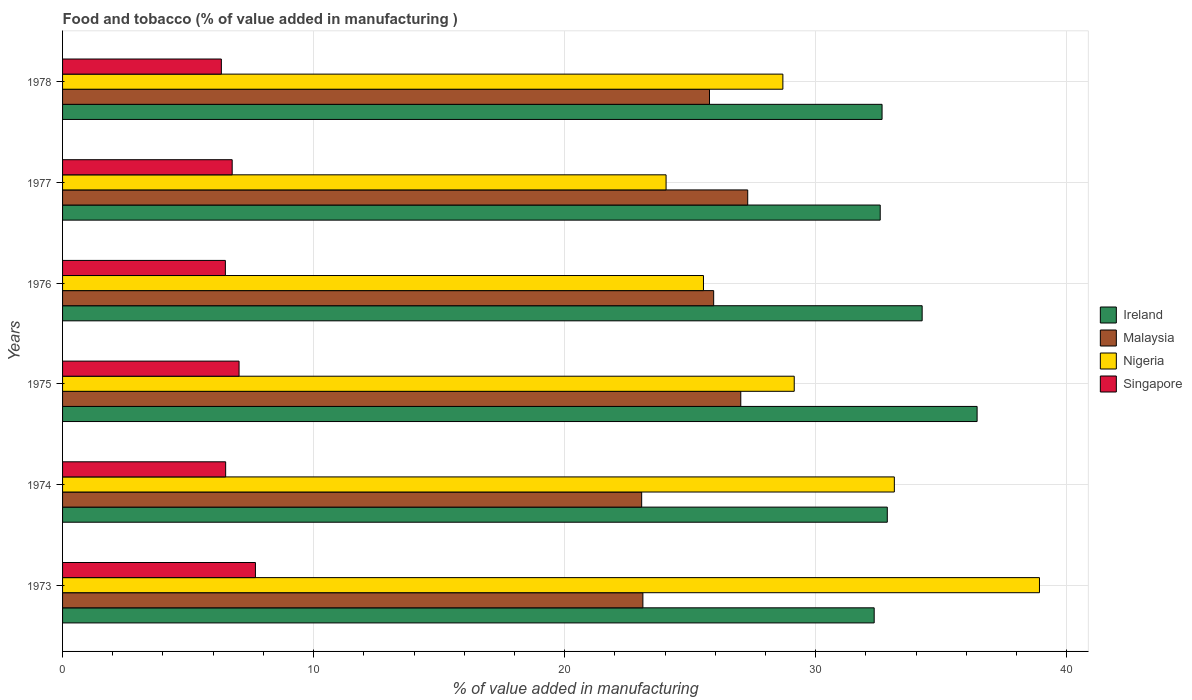Are the number of bars per tick equal to the number of legend labels?
Offer a very short reply. Yes. Are the number of bars on each tick of the Y-axis equal?
Keep it short and to the point. Yes. How many bars are there on the 1st tick from the top?
Provide a succinct answer. 4. What is the label of the 4th group of bars from the top?
Your answer should be compact. 1975. What is the value added in manufacturing food and tobacco in Malaysia in 1977?
Your response must be concise. 27.29. Across all years, what is the maximum value added in manufacturing food and tobacco in Nigeria?
Offer a terse response. 38.91. Across all years, what is the minimum value added in manufacturing food and tobacco in Malaysia?
Your answer should be compact. 23.07. In which year was the value added in manufacturing food and tobacco in Nigeria maximum?
Ensure brevity in your answer.  1973. In which year was the value added in manufacturing food and tobacco in Nigeria minimum?
Offer a very short reply. 1977. What is the total value added in manufacturing food and tobacco in Singapore in the graph?
Keep it short and to the point. 40.78. What is the difference between the value added in manufacturing food and tobacco in Nigeria in 1974 and that in 1975?
Provide a succinct answer. 3.99. What is the difference between the value added in manufacturing food and tobacco in Malaysia in 1978 and the value added in manufacturing food and tobacco in Ireland in 1974?
Offer a terse response. -7.08. What is the average value added in manufacturing food and tobacco in Singapore per year?
Your answer should be very brief. 6.8. In the year 1978, what is the difference between the value added in manufacturing food and tobacco in Ireland and value added in manufacturing food and tobacco in Singapore?
Make the answer very short. 26.32. What is the ratio of the value added in manufacturing food and tobacco in Ireland in 1974 to that in 1978?
Keep it short and to the point. 1.01. What is the difference between the highest and the second highest value added in manufacturing food and tobacco in Malaysia?
Make the answer very short. 0.28. What is the difference between the highest and the lowest value added in manufacturing food and tobacco in Malaysia?
Provide a succinct answer. 4.22. Is the sum of the value added in manufacturing food and tobacco in Malaysia in 1975 and 1978 greater than the maximum value added in manufacturing food and tobacco in Nigeria across all years?
Offer a terse response. Yes. Is it the case that in every year, the sum of the value added in manufacturing food and tobacco in Malaysia and value added in manufacturing food and tobacco in Nigeria is greater than the sum of value added in manufacturing food and tobacco in Ireland and value added in manufacturing food and tobacco in Singapore?
Make the answer very short. Yes. What does the 4th bar from the top in 1978 represents?
Ensure brevity in your answer.  Ireland. What does the 1st bar from the bottom in 1975 represents?
Your answer should be compact. Ireland. Are all the bars in the graph horizontal?
Your answer should be very brief. Yes. Are the values on the major ticks of X-axis written in scientific E-notation?
Offer a terse response. No. Does the graph contain any zero values?
Ensure brevity in your answer.  No. Where does the legend appear in the graph?
Your answer should be very brief. Center right. How are the legend labels stacked?
Provide a short and direct response. Vertical. What is the title of the graph?
Offer a very short reply. Food and tobacco (% of value added in manufacturing ). What is the label or title of the X-axis?
Provide a succinct answer. % of value added in manufacturing. What is the label or title of the Y-axis?
Ensure brevity in your answer.  Years. What is the % of value added in manufacturing in Ireland in 1973?
Your response must be concise. 32.33. What is the % of value added in manufacturing of Malaysia in 1973?
Provide a short and direct response. 23.12. What is the % of value added in manufacturing of Nigeria in 1973?
Your response must be concise. 38.91. What is the % of value added in manufacturing in Singapore in 1973?
Keep it short and to the point. 7.68. What is the % of value added in manufacturing of Ireland in 1974?
Provide a succinct answer. 32.85. What is the % of value added in manufacturing of Malaysia in 1974?
Offer a terse response. 23.07. What is the % of value added in manufacturing of Nigeria in 1974?
Keep it short and to the point. 33.13. What is the % of value added in manufacturing in Singapore in 1974?
Provide a short and direct response. 6.5. What is the % of value added in manufacturing in Ireland in 1975?
Provide a succinct answer. 36.43. What is the % of value added in manufacturing of Malaysia in 1975?
Your answer should be very brief. 27.02. What is the % of value added in manufacturing of Nigeria in 1975?
Provide a succinct answer. 29.15. What is the % of value added in manufacturing of Singapore in 1975?
Provide a short and direct response. 7.03. What is the % of value added in manufacturing in Ireland in 1976?
Ensure brevity in your answer.  34.24. What is the % of value added in manufacturing of Malaysia in 1976?
Give a very brief answer. 25.94. What is the % of value added in manufacturing of Nigeria in 1976?
Make the answer very short. 25.53. What is the % of value added in manufacturing of Singapore in 1976?
Offer a terse response. 6.49. What is the % of value added in manufacturing of Ireland in 1977?
Give a very brief answer. 32.57. What is the % of value added in manufacturing of Malaysia in 1977?
Keep it short and to the point. 27.29. What is the % of value added in manufacturing in Nigeria in 1977?
Provide a succinct answer. 24.04. What is the % of value added in manufacturing in Singapore in 1977?
Ensure brevity in your answer.  6.76. What is the % of value added in manufacturing in Ireland in 1978?
Ensure brevity in your answer.  32.64. What is the % of value added in manufacturing in Malaysia in 1978?
Provide a short and direct response. 25.77. What is the % of value added in manufacturing of Nigeria in 1978?
Keep it short and to the point. 28.69. What is the % of value added in manufacturing of Singapore in 1978?
Ensure brevity in your answer.  6.33. Across all years, what is the maximum % of value added in manufacturing in Ireland?
Offer a very short reply. 36.43. Across all years, what is the maximum % of value added in manufacturing of Malaysia?
Your response must be concise. 27.29. Across all years, what is the maximum % of value added in manufacturing of Nigeria?
Keep it short and to the point. 38.91. Across all years, what is the maximum % of value added in manufacturing of Singapore?
Make the answer very short. 7.68. Across all years, what is the minimum % of value added in manufacturing in Ireland?
Ensure brevity in your answer.  32.33. Across all years, what is the minimum % of value added in manufacturing in Malaysia?
Offer a very short reply. 23.07. Across all years, what is the minimum % of value added in manufacturing of Nigeria?
Provide a short and direct response. 24.04. Across all years, what is the minimum % of value added in manufacturing in Singapore?
Make the answer very short. 6.33. What is the total % of value added in manufacturing in Ireland in the graph?
Your response must be concise. 201.07. What is the total % of value added in manufacturing of Malaysia in the graph?
Your answer should be very brief. 152.2. What is the total % of value added in manufacturing of Nigeria in the graph?
Offer a terse response. 179.46. What is the total % of value added in manufacturing of Singapore in the graph?
Offer a very short reply. 40.78. What is the difference between the % of value added in manufacturing of Ireland in 1973 and that in 1974?
Make the answer very short. -0.52. What is the difference between the % of value added in manufacturing of Malaysia in 1973 and that in 1974?
Ensure brevity in your answer.  0.05. What is the difference between the % of value added in manufacturing of Nigeria in 1973 and that in 1974?
Make the answer very short. 5.78. What is the difference between the % of value added in manufacturing in Singapore in 1973 and that in 1974?
Offer a terse response. 1.19. What is the difference between the % of value added in manufacturing in Malaysia in 1973 and that in 1975?
Keep it short and to the point. -3.9. What is the difference between the % of value added in manufacturing in Nigeria in 1973 and that in 1975?
Provide a short and direct response. 9.77. What is the difference between the % of value added in manufacturing in Singapore in 1973 and that in 1975?
Offer a very short reply. 0.65. What is the difference between the % of value added in manufacturing in Ireland in 1973 and that in 1976?
Offer a very short reply. -1.91. What is the difference between the % of value added in manufacturing of Malaysia in 1973 and that in 1976?
Make the answer very short. -2.82. What is the difference between the % of value added in manufacturing in Nigeria in 1973 and that in 1976?
Your response must be concise. 13.38. What is the difference between the % of value added in manufacturing in Singapore in 1973 and that in 1976?
Give a very brief answer. 1.2. What is the difference between the % of value added in manufacturing in Ireland in 1973 and that in 1977?
Keep it short and to the point. -0.24. What is the difference between the % of value added in manufacturing in Malaysia in 1973 and that in 1977?
Ensure brevity in your answer.  -4.18. What is the difference between the % of value added in manufacturing in Nigeria in 1973 and that in 1977?
Your response must be concise. 14.87. What is the difference between the % of value added in manufacturing in Singapore in 1973 and that in 1977?
Offer a very short reply. 0.93. What is the difference between the % of value added in manufacturing in Ireland in 1973 and that in 1978?
Provide a short and direct response. -0.31. What is the difference between the % of value added in manufacturing of Malaysia in 1973 and that in 1978?
Keep it short and to the point. -2.65. What is the difference between the % of value added in manufacturing of Nigeria in 1973 and that in 1978?
Ensure brevity in your answer.  10.22. What is the difference between the % of value added in manufacturing of Singapore in 1973 and that in 1978?
Your answer should be very brief. 1.36. What is the difference between the % of value added in manufacturing in Ireland in 1974 and that in 1975?
Offer a terse response. -3.58. What is the difference between the % of value added in manufacturing of Malaysia in 1974 and that in 1975?
Ensure brevity in your answer.  -3.95. What is the difference between the % of value added in manufacturing of Nigeria in 1974 and that in 1975?
Provide a succinct answer. 3.99. What is the difference between the % of value added in manufacturing in Singapore in 1974 and that in 1975?
Provide a short and direct response. -0.53. What is the difference between the % of value added in manufacturing of Ireland in 1974 and that in 1976?
Your response must be concise. -1.39. What is the difference between the % of value added in manufacturing in Malaysia in 1974 and that in 1976?
Your answer should be very brief. -2.87. What is the difference between the % of value added in manufacturing of Nigeria in 1974 and that in 1976?
Give a very brief answer. 7.6. What is the difference between the % of value added in manufacturing of Singapore in 1974 and that in 1976?
Offer a terse response. 0.01. What is the difference between the % of value added in manufacturing of Ireland in 1974 and that in 1977?
Give a very brief answer. 0.28. What is the difference between the % of value added in manufacturing of Malaysia in 1974 and that in 1977?
Offer a terse response. -4.22. What is the difference between the % of value added in manufacturing in Nigeria in 1974 and that in 1977?
Keep it short and to the point. 9.09. What is the difference between the % of value added in manufacturing of Singapore in 1974 and that in 1977?
Your response must be concise. -0.26. What is the difference between the % of value added in manufacturing in Ireland in 1974 and that in 1978?
Your answer should be very brief. 0.21. What is the difference between the % of value added in manufacturing of Malaysia in 1974 and that in 1978?
Keep it short and to the point. -2.7. What is the difference between the % of value added in manufacturing in Nigeria in 1974 and that in 1978?
Provide a succinct answer. 4.44. What is the difference between the % of value added in manufacturing of Singapore in 1974 and that in 1978?
Provide a short and direct response. 0.17. What is the difference between the % of value added in manufacturing of Ireland in 1975 and that in 1976?
Offer a terse response. 2.19. What is the difference between the % of value added in manufacturing in Malaysia in 1975 and that in 1976?
Keep it short and to the point. 1.08. What is the difference between the % of value added in manufacturing in Nigeria in 1975 and that in 1976?
Give a very brief answer. 3.62. What is the difference between the % of value added in manufacturing in Singapore in 1975 and that in 1976?
Offer a terse response. 0.55. What is the difference between the % of value added in manufacturing in Ireland in 1975 and that in 1977?
Ensure brevity in your answer.  3.86. What is the difference between the % of value added in manufacturing in Malaysia in 1975 and that in 1977?
Your response must be concise. -0.28. What is the difference between the % of value added in manufacturing of Nigeria in 1975 and that in 1977?
Provide a succinct answer. 5.11. What is the difference between the % of value added in manufacturing in Singapore in 1975 and that in 1977?
Your response must be concise. 0.27. What is the difference between the % of value added in manufacturing in Ireland in 1975 and that in 1978?
Ensure brevity in your answer.  3.79. What is the difference between the % of value added in manufacturing of Malaysia in 1975 and that in 1978?
Offer a terse response. 1.25. What is the difference between the % of value added in manufacturing of Nigeria in 1975 and that in 1978?
Your answer should be very brief. 0.45. What is the difference between the % of value added in manufacturing of Singapore in 1975 and that in 1978?
Ensure brevity in your answer.  0.71. What is the difference between the % of value added in manufacturing of Ireland in 1976 and that in 1977?
Make the answer very short. 1.67. What is the difference between the % of value added in manufacturing of Malaysia in 1976 and that in 1977?
Keep it short and to the point. -1.36. What is the difference between the % of value added in manufacturing of Nigeria in 1976 and that in 1977?
Ensure brevity in your answer.  1.49. What is the difference between the % of value added in manufacturing of Singapore in 1976 and that in 1977?
Your response must be concise. -0.27. What is the difference between the % of value added in manufacturing of Ireland in 1976 and that in 1978?
Offer a very short reply. 1.6. What is the difference between the % of value added in manufacturing of Malaysia in 1976 and that in 1978?
Offer a terse response. 0.17. What is the difference between the % of value added in manufacturing of Nigeria in 1976 and that in 1978?
Keep it short and to the point. -3.16. What is the difference between the % of value added in manufacturing in Singapore in 1976 and that in 1978?
Ensure brevity in your answer.  0.16. What is the difference between the % of value added in manufacturing in Ireland in 1977 and that in 1978?
Keep it short and to the point. -0.07. What is the difference between the % of value added in manufacturing in Malaysia in 1977 and that in 1978?
Make the answer very short. 1.52. What is the difference between the % of value added in manufacturing in Nigeria in 1977 and that in 1978?
Offer a very short reply. -4.65. What is the difference between the % of value added in manufacturing in Singapore in 1977 and that in 1978?
Your answer should be very brief. 0.43. What is the difference between the % of value added in manufacturing in Ireland in 1973 and the % of value added in manufacturing in Malaysia in 1974?
Ensure brevity in your answer.  9.26. What is the difference between the % of value added in manufacturing in Ireland in 1973 and the % of value added in manufacturing in Nigeria in 1974?
Ensure brevity in your answer.  -0.8. What is the difference between the % of value added in manufacturing of Ireland in 1973 and the % of value added in manufacturing of Singapore in 1974?
Your answer should be compact. 25.83. What is the difference between the % of value added in manufacturing of Malaysia in 1973 and the % of value added in manufacturing of Nigeria in 1974?
Provide a short and direct response. -10.02. What is the difference between the % of value added in manufacturing of Malaysia in 1973 and the % of value added in manufacturing of Singapore in 1974?
Your answer should be compact. 16.62. What is the difference between the % of value added in manufacturing in Nigeria in 1973 and the % of value added in manufacturing in Singapore in 1974?
Offer a very short reply. 32.42. What is the difference between the % of value added in manufacturing in Ireland in 1973 and the % of value added in manufacturing in Malaysia in 1975?
Make the answer very short. 5.31. What is the difference between the % of value added in manufacturing of Ireland in 1973 and the % of value added in manufacturing of Nigeria in 1975?
Make the answer very short. 3.18. What is the difference between the % of value added in manufacturing of Ireland in 1973 and the % of value added in manufacturing of Singapore in 1975?
Your answer should be very brief. 25.3. What is the difference between the % of value added in manufacturing of Malaysia in 1973 and the % of value added in manufacturing of Nigeria in 1975?
Give a very brief answer. -6.03. What is the difference between the % of value added in manufacturing in Malaysia in 1973 and the % of value added in manufacturing in Singapore in 1975?
Offer a terse response. 16.09. What is the difference between the % of value added in manufacturing of Nigeria in 1973 and the % of value added in manufacturing of Singapore in 1975?
Your answer should be compact. 31.88. What is the difference between the % of value added in manufacturing of Ireland in 1973 and the % of value added in manufacturing of Malaysia in 1976?
Keep it short and to the point. 6.39. What is the difference between the % of value added in manufacturing in Ireland in 1973 and the % of value added in manufacturing in Nigeria in 1976?
Your answer should be very brief. 6.8. What is the difference between the % of value added in manufacturing of Ireland in 1973 and the % of value added in manufacturing of Singapore in 1976?
Ensure brevity in your answer.  25.84. What is the difference between the % of value added in manufacturing in Malaysia in 1973 and the % of value added in manufacturing in Nigeria in 1976?
Provide a short and direct response. -2.41. What is the difference between the % of value added in manufacturing in Malaysia in 1973 and the % of value added in manufacturing in Singapore in 1976?
Your response must be concise. 16.63. What is the difference between the % of value added in manufacturing of Nigeria in 1973 and the % of value added in manufacturing of Singapore in 1976?
Offer a terse response. 32.43. What is the difference between the % of value added in manufacturing in Ireland in 1973 and the % of value added in manufacturing in Malaysia in 1977?
Provide a short and direct response. 5.04. What is the difference between the % of value added in manufacturing of Ireland in 1973 and the % of value added in manufacturing of Nigeria in 1977?
Ensure brevity in your answer.  8.29. What is the difference between the % of value added in manufacturing of Ireland in 1973 and the % of value added in manufacturing of Singapore in 1977?
Provide a succinct answer. 25.57. What is the difference between the % of value added in manufacturing of Malaysia in 1973 and the % of value added in manufacturing of Nigeria in 1977?
Provide a short and direct response. -0.92. What is the difference between the % of value added in manufacturing of Malaysia in 1973 and the % of value added in manufacturing of Singapore in 1977?
Your answer should be compact. 16.36. What is the difference between the % of value added in manufacturing in Nigeria in 1973 and the % of value added in manufacturing in Singapore in 1977?
Your answer should be very brief. 32.16. What is the difference between the % of value added in manufacturing in Ireland in 1973 and the % of value added in manufacturing in Malaysia in 1978?
Provide a short and direct response. 6.56. What is the difference between the % of value added in manufacturing of Ireland in 1973 and the % of value added in manufacturing of Nigeria in 1978?
Your answer should be very brief. 3.64. What is the difference between the % of value added in manufacturing of Ireland in 1973 and the % of value added in manufacturing of Singapore in 1978?
Provide a succinct answer. 26. What is the difference between the % of value added in manufacturing of Malaysia in 1973 and the % of value added in manufacturing of Nigeria in 1978?
Offer a terse response. -5.58. What is the difference between the % of value added in manufacturing of Malaysia in 1973 and the % of value added in manufacturing of Singapore in 1978?
Give a very brief answer. 16.79. What is the difference between the % of value added in manufacturing of Nigeria in 1973 and the % of value added in manufacturing of Singapore in 1978?
Make the answer very short. 32.59. What is the difference between the % of value added in manufacturing in Ireland in 1974 and the % of value added in manufacturing in Malaysia in 1975?
Ensure brevity in your answer.  5.84. What is the difference between the % of value added in manufacturing of Ireland in 1974 and the % of value added in manufacturing of Nigeria in 1975?
Your response must be concise. 3.71. What is the difference between the % of value added in manufacturing of Ireland in 1974 and the % of value added in manufacturing of Singapore in 1975?
Provide a succinct answer. 25.82. What is the difference between the % of value added in manufacturing in Malaysia in 1974 and the % of value added in manufacturing in Nigeria in 1975?
Provide a short and direct response. -6.08. What is the difference between the % of value added in manufacturing in Malaysia in 1974 and the % of value added in manufacturing in Singapore in 1975?
Keep it short and to the point. 16.04. What is the difference between the % of value added in manufacturing in Nigeria in 1974 and the % of value added in manufacturing in Singapore in 1975?
Provide a succinct answer. 26.1. What is the difference between the % of value added in manufacturing of Ireland in 1974 and the % of value added in manufacturing of Malaysia in 1976?
Your answer should be very brief. 6.92. What is the difference between the % of value added in manufacturing of Ireland in 1974 and the % of value added in manufacturing of Nigeria in 1976?
Make the answer very short. 7.32. What is the difference between the % of value added in manufacturing in Ireland in 1974 and the % of value added in manufacturing in Singapore in 1976?
Your response must be concise. 26.37. What is the difference between the % of value added in manufacturing of Malaysia in 1974 and the % of value added in manufacturing of Nigeria in 1976?
Provide a short and direct response. -2.46. What is the difference between the % of value added in manufacturing in Malaysia in 1974 and the % of value added in manufacturing in Singapore in 1976?
Ensure brevity in your answer.  16.58. What is the difference between the % of value added in manufacturing in Nigeria in 1974 and the % of value added in manufacturing in Singapore in 1976?
Offer a very short reply. 26.65. What is the difference between the % of value added in manufacturing in Ireland in 1974 and the % of value added in manufacturing in Malaysia in 1977?
Your response must be concise. 5.56. What is the difference between the % of value added in manufacturing in Ireland in 1974 and the % of value added in manufacturing in Nigeria in 1977?
Ensure brevity in your answer.  8.81. What is the difference between the % of value added in manufacturing in Ireland in 1974 and the % of value added in manufacturing in Singapore in 1977?
Keep it short and to the point. 26.1. What is the difference between the % of value added in manufacturing of Malaysia in 1974 and the % of value added in manufacturing of Nigeria in 1977?
Ensure brevity in your answer.  -0.97. What is the difference between the % of value added in manufacturing of Malaysia in 1974 and the % of value added in manufacturing of Singapore in 1977?
Your response must be concise. 16.31. What is the difference between the % of value added in manufacturing in Nigeria in 1974 and the % of value added in manufacturing in Singapore in 1977?
Offer a very short reply. 26.38. What is the difference between the % of value added in manufacturing of Ireland in 1974 and the % of value added in manufacturing of Malaysia in 1978?
Provide a short and direct response. 7.08. What is the difference between the % of value added in manufacturing in Ireland in 1974 and the % of value added in manufacturing in Nigeria in 1978?
Provide a short and direct response. 4.16. What is the difference between the % of value added in manufacturing of Ireland in 1974 and the % of value added in manufacturing of Singapore in 1978?
Your response must be concise. 26.53. What is the difference between the % of value added in manufacturing in Malaysia in 1974 and the % of value added in manufacturing in Nigeria in 1978?
Offer a very short reply. -5.63. What is the difference between the % of value added in manufacturing in Malaysia in 1974 and the % of value added in manufacturing in Singapore in 1978?
Provide a short and direct response. 16.74. What is the difference between the % of value added in manufacturing of Nigeria in 1974 and the % of value added in manufacturing of Singapore in 1978?
Your answer should be very brief. 26.81. What is the difference between the % of value added in manufacturing of Ireland in 1975 and the % of value added in manufacturing of Malaysia in 1976?
Keep it short and to the point. 10.49. What is the difference between the % of value added in manufacturing in Ireland in 1975 and the % of value added in manufacturing in Nigeria in 1976?
Your answer should be very brief. 10.9. What is the difference between the % of value added in manufacturing of Ireland in 1975 and the % of value added in manufacturing of Singapore in 1976?
Ensure brevity in your answer.  29.95. What is the difference between the % of value added in manufacturing in Malaysia in 1975 and the % of value added in manufacturing in Nigeria in 1976?
Make the answer very short. 1.49. What is the difference between the % of value added in manufacturing in Malaysia in 1975 and the % of value added in manufacturing in Singapore in 1976?
Offer a very short reply. 20.53. What is the difference between the % of value added in manufacturing in Nigeria in 1975 and the % of value added in manufacturing in Singapore in 1976?
Give a very brief answer. 22.66. What is the difference between the % of value added in manufacturing of Ireland in 1975 and the % of value added in manufacturing of Malaysia in 1977?
Provide a succinct answer. 9.14. What is the difference between the % of value added in manufacturing in Ireland in 1975 and the % of value added in manufacturing in Nigeria in 1977?
Ensure brevity in your answer.  12.39. What is the difference between the % of value added in manufacturing in Ireland in 1975 and the % of value added in manufacturing in Singapore in 1977?
Keep it short and to the point. 29.67. What is the difference between the % of value added in manufacturing of Malaysia in 1975 and the % of value added in manufacturing of Nigeria in 1977?
Your answer should be compact. 2.98. What is the difference between the % of value added in manufacturing of Malaysia in 1975 and the % of value added in manufacturing of Singapore in 1977?
Provide a succinct answer. 20.26. What is the difference between the % of value added in manufacturing of Nigeria in 1975 and the % of value added in manufacturing of Singapore in 1977?
Make the answer very short. 22.39. What is the difference between the % of value added in manufacturing of Ireland in 1975 and the % of value added in manufacturing of Malaysia in 1978?
Ensure brevity in your answer.  10.66. What is the difference between the % of value added in manufacturing of Ireland in 1975 and the % of value added in manufacturing of Nigeria in 1978?
Your answer should be compact. 7.74. What is the difference between the % of value added in manufacturing in Ireland in 1975 and the % of value added in manufacturing in Singapore in 1978?
Provide a short and direct response. 30.1. What is the difference between the % of value added in manufacturing of Malaysia in 1975 and the % of value added in manufacturing of Nigeria in 1978?
Your answer should be compact. -1.68. What is the difference between the % of value added in manufacturing in Malaysia in 1975 and the % of value added in manufacturing in Singapore in 1978?
Offer a very short reply. 20.69. What is the difference between the % of value added in manufacturing in Nigeria in 1975 and the % of value added in manufacturing in Singapore in 1978?
Provide a succinct answer. 22.82. What is the difference between the % of value added in manufacturing of Ireland in 1976 and the % of value added in manufacturing of Malaysia in 1977?
Offer a very short reply. 6.95. What is the difference between the % of value added in manufacturing of Ireland in 1976 and the % of value added in manufacturing of Nigeria in 1977?
Your answer should be very brief. 10.2. What is the difference between the % of value added in manufacturing of Ireland in 1976 and the % of value added in manufacturing of Singapore in 1977?
Offer a very short reply. 27.48. What is the difference between the % of value added in manufacturing in Malaysia in 1976 and the % of value added in manufacturing in Nigeria in 1977?
Make the answer very short. 1.9. What is the difference between the % of value added in manufacturing in Malaysia in 1976 and the % of value added in manufacturing in Singapore in 1977?
Provide a short and direct response. 19.18. What is the difference between the % of value added in manufacturing of Nigeria in 1976 and the % of value added in manufacturing of Singapore in 1977?
Your answer should be compact. 18.77. What is the difference between the % of value added in manufacturing in Ireland in 1976 and the % of value added in manufacturing in Malaysia in 1978?
Your answer should be compact. 8.47. What is the difference between the % of value added in manufacturing in Ireland in 1976 and the % of value added in manufacturing in Nigeria in 1978?
Make the answer very short. 5.55. What is the difference between the % of value added in manufacturing in Ireland in 1976 and the % of value added in manufacturing in Singapore in 1978?
Keep it short and to the point. 27.92. What is the difference between the % of value added in manufacturing in Malaysia in 1976 and the % of value added in manufacturing in Nigeria in 1978?
Provide a succinct answer. -2.76. What is the difference between the % of value added in manufacturing of Malaysia in 1976 and the % of value added in manufacturing of Singapore in 1978?
Give a very brief answer. 19.61. What is the difference between the % of value added in manufacturing in Nigeria in 1976 and the % of value added in manufacturing in Singapore in 1978?
Your answer should be compact. 19.2. What is the difference between the % of value added in manufacturing of Ireland in 1977 and the % of value added in manufacturing of Malaysia in 1978?
Your response must be concise. 6.8. What is the difference between the % of value added in manufacturing in Ireland in 1977 and the % of value added in manufacturing in Nigeria in 1978?
Your response must be concise. 3.88. What is the difference between the % of value added in manufacturing in Ireland in 1977 and the % of value added in manufacturing in Singapore in 1978?
Ensure brevity in your answer.  26.25. What is the difference between the % of value added in manufacturing of Malaysia in 1977 and the % of value added in manufacturing of Nigeria in 1978?
Your response must be concise. -1.4. What is the difference between the % of value added in manufacturing in Malaysia in 1977 and the % of value added in manufacturing in Singapore in 1978?
Make the answer very short. 20.97. What is the difference between the % of value added in manufacturing of Nigeria in 1977 and the % of value added in manufacturing of Singapore in 1978?
Provide a short and direct response. 17.72. What is the average % of value added in manufacturing in Ireland per year?
Ensure brevity in your answer.  33.51. What is the average % of value added in manufacturing in Malaysia per year?
Keep it short and to the point. 25.37. What is the average % of value added in manufacturing in Nigeria per year?
Your response must be concise. 29.91. What is the average % of value added in manufacturing of Singapore per year?
Offer a very short reply. 6.8. In the year 1973, what is the difference between the % of value added in manufacturing of Ireland and % of value added in manufacturing of Malaysia?
Offer a very short reply. 9.21. In the year 1973, what is the difference between the % of value added in manufacturing in Ireland and % of value added in manufacturing in Nigeria?
Your answer should be compact. -6.58. In the year 1973, what is the difference between the % of value added in manufacturing of Ireland and % of value added in manufacturing of Singapore?
Your answer should be compact. 24.65. In the year 1973, what is the difference between the % of value added in manufacturing of Malaysia and % of value added in manufacturing of Nigeria?
Ensure brevity in your answer.  -15.8. In the year 1973, what is the difference between the % of value added in manufacturing of Malaysia and % of value added in manufacturing of Singapore?
Give a very brief answer. 15.43. In the year 1973, what is the difference between the % of value added in manufacturing of Nigeria and % of value added in manufacturing of Singapore?
Offer a terse response. 31.23. In the year 1974, what is the difference between the % of value added in manufacturing of Ireland and % of value added in manufacturing of Malaysia?
Offer a terse response. 9.78. In the year 1974, what is the difference between the % of value added in manufacturing in Ireland and % of value added in manufacturing in Nigeria?
Make the answer very short. -0.28. In the year 1974, what is the difference between the % of value added in manufacturing in Ireland and % of value added in manufacturing in Singapore?
Give a very brief answer. 26.36. In the year 1974, what is the difference between the % of value added in manufacturing in Malaysia and % of value added in manufacturing in Nigeria?
Ensure brevity in your answer.  -10.07. In the year 1974, what is the difference between the % of value added in manufacturing in Malaysia and % of value added in manufacturing in Singapore?
Make the answer very short. 16.57. In the year 1974, what is the difference between the % of value added in manufacturing in Nigeria and % of value added in manufacturing in Singapore?
Offer a terse response. 26.64. In the year 1975, what is the difference between the % of value added in manufacturing of Ireland and % of value added in manufacturing of Malaysia?
Your answer should be compact. 9.41. In the year 1975, what is the difference between the % of value added in manufacturing of Ireland and % of value added in manufacturing of Nigeria?
Your answer should be compact. 7.28. In the year 1975, what is the difference between the % of value added in manufacturing of Ireland and % of value added in manufacturing of Singapore?
Offer a very short reply. 29.4. In the year 1975, what is the difference between the % of value added in manufacturing of Malaysia and % of value added in manufacturing of Nigeria?
Keep it short and to the point. -2.13. In the year 1975, what is the difference between the % of value added in manufacturing in Malaysia and % of value added in manufacturing in Singapore?
Your answer should be very brief. 19.99. In the year 1975, what is the difference between the % of value added in manufacturing in Nigeria and % of value added in manufacturing in Singapore?
Your answer should be very brief. 22.12. In the year 1976, what is the difference between the % of value added in manufacturing of Ireland and % of value added in manufacturing of Malaysia?
Give a very brief answer. 8.3. In the year 1976, what is the difference between the % of value added in manufacturing in Ireland and % of value added in manufacturing in Nigeria?
Offer a very short reply. 8.71. In the year 1976, what is the difference between the % of value added in manufacturing of Ireland and % of value added in manufacturing of Singapore?
Your answer should be compact. 27.76. In the year 1976, what is the difference between the % of value added in manufacturing of Malaysia and % of value added in manufacturing of Nigeria?
Provide a succinct answer. 0.41. In the year 1976, what is the difference between the % of value added in manufacturing in Malaysia and % of value added in manufacturing in Singapore?
Give a very brief answer. 19.45. In the year 1976, what is the difference between the % of value added in manufacturing of Nigeria and % of value added in manufacturing of Singapore?
Your response must be concise. 19.04. In the year 1977, what is the difference between the % of value added in manufacturing in Ireland and % of value added in manufacturing in Malaysia?
Your response must be concise. 5.28. In the year 1977, what is the difference between the % of value added in manufacturing of Ireland and % of value added in manufacturing of Nigeria?
Provide a short and direct response. 8.53. In the year 1977, what is the difference between the % of value added in manufacturing in Ireland and % of value added in manufacturing in Singapore?
Your answer should be very brief. 25.81. In the year 1977, what is the difference between the % of value added in manufacturing in Malaysia and % of value added in manufacturing in Nigeria?
Provide a short and direct response. 3.25. In the year 1977, what is the difference between the % of value added in manufacturing of Malaysia and % of value added in manufacturing of Singapore?
Your answer should be compact. 20.54. In the year 1977, what is the difference between the % of value added in manufacturing of Nigeria and % of value added in manufacturing of Singapore?
Ensure brevity in your answer.  17.28. In the year 1978, what is the difference between the % of value added in manufacturing of Ireland and % of value added in manufacturing of Malaysia?
Offer a terse response. 6.87. In the year 1978, what is the difference between the % of value added in manufacturing in Ireland and % of value added in manufacturing in Nigeria?
Ensure brevity in your answer.  3.95. In the year 1978, what is the difference between the % of value added in manufacturing of Ireland and % of value added in manufacturing of Singapore?
Provide a short and direct response. 26.32. In the year 1978, what is the difference between the % of value added in manufacturing of Malaysia and % of value added in manufacturing of Nigeria?
Make the answer very short. -2.92. In the year 1978, what is the difference between the % of value added in manufacturing in Malaysia and % of value added in manufacturing in Singapore?
Make the answer very short. 19.44. In the year 1978, what is the difference between the % of value added in manufacturing of Nigeria and % of value added in manufacturing of Singapore?
Your answer should be very brief. 22.37. What is the ratio of the % of value added in manufacturing of Ireland in 1973 to that in 1974?
Your answer should be compact. 0.98. What is the ratio of the % of value added in manufacturing in Malaysia in 1973 to that in 1974?
Your answer should be compact. 1. What is the ratio of the % of value added in manufacturing in Nigeria in 1973 to that in 1974?
Ensure brevity in your answer.  1.17. What is the ratio of the % of value added in manufacturing in Singapore in 1973 to that in 1974?
Give a very brief answer. 1.18. What is the ratio of the % of value added in manufacturing of Ireland in 1973 to that in 1975?
Offer a very short reply. 0.89. What is the ratio of the % of value added in manufacturing in Malaysia in 1973 to that in 1975?
Provide a short and direct response. 0.86. What is the ratio of the % of value added in manufacturing of Nigeria in 1973 to that in 1975?
Keep it short and to the point. 1.34. What is the ratio of the % of value added in manufacturing of Singapore in 1973 to that in 1975?
Ensure brevity in your answer.  1.09. What is the ratio of the % of value added in manufacturing of Ireland in 1973 to that in 1976?
Provide a succinct answer. 0.94. What is the ratio of the % of value added in manufacturing in Malaysia in 1973 to that in 1976?
Provide a succinct answer. 0.89. What is the ratio of the % of value added in manufacturing in Nigeria in 1973 to that in 1976?
Provide a succinct answer. 1.52. What is the ratio of the % of value added in manufacturing in Singapore in 1973 to that in 1976?
Give a very brief answer. 1.18. What is the ratio of the % of value added in manufacturing of Malaysia in 1973 to that in 1977?
Give a very brief answer. 0.85. What is the ratio of the % of value added in manufacturing of Nigeria in 1973 to that in 1977?
Keep it short and to the point. 1.62. What is the ratio of the % of value added in manufacturing in Singapore in 1973 to that in 1977?
Offer a very short reply. 1.14. What is the ratio of the % of value added in manufacturing in Ireland in 1973 to that in 1978?
Your answer should be compact. 0.99. What is the ratio of the % of value added in manufacturing of Malaysia in 1973 to that in 1978?
Give a very brief answer. 0.9. What is the ratio of the % of value added in manufacturing in Nigeria in 1973 to that in 1978?
Your response must be concise. 1.36. What is the ratio of the % of value added in manufacturing of Singapore in 1973 to that in 1978?
Offer a terse response. 1.21. What is the ratio of the % of value added in manufacturing in Ireland in 1974 to that in 1975?
Your answer should be compact. 0.9. What is the ratio of the % of value added in manufacturing of Malaysia in 1974 to that in 1975?
Offer a terse response. 0.85. What is the ratio of the % of value added in manufacturing in Nigeria in 1974 to that in 1975?
Provide a short and direct response. 1.14. What is the ratio of the % of value added in manufacturing of Singapore in 1974 to that in 1975?
Your answer should be very brief. 0.92. What is the ratio of the % of value added in manufacturing of Ireland in 1974 to that in 1976?
Provide a short and direct response. 0.96. What is the ratio of the % of value added in manufacturing in Malaysia in 1974 to that in 1976?
Your answer should be very brief. 0.89. What is the ratio of the % of value added in manufacturing in Nigeria in 1974 to that in 1976?
Keep it short and to the point. 1.3. What is the ratio of the % of value added in manufacturing of Ireland in 1974 to that in 1977?
Ensure brevity in your answer.  1.01. What is the ratio of the % of value added in manufacturing of Malaysia in 1974 to that in 1977?
Your response must be concise. 0.85. What is the ratio of the % of value added in manufacturing in Nigeria in 1974 to that in 1977?
Your response must be concise. 1.38. What is the ratio of the % of value added in manufacturing of Singapore in 1974 to that in 1977?
Your answer should be compact. 0.96. What is the ratio of the % of value added in manufacturing of Ireland in 1974 to that in 1978?
Offer a very short reply. 1.01. What is the ratio of the % of value added in manufacturing of Malaysia in 1974 to that in 1978?
Your answer should be very brief. 0.9. What is the ratio of the % of value added in manufacturing of Nigeria in 1974 to that in 1978?
Your answer should be compact. 1.15. What is the ratio of the % of value added in manufacturing in Ireland in 1975 to that in 1976?
Ensure brevity in your answer.  1.06. What is the ratio of the % of value added in manufacturing of Malaysia in 1975 to that in 1976?
Make the answer very short. 1.04. What is the ratio of the % of value added in manufacturing of Nigeria in 1975 to that in 1976?
Keep it short and to the point. 1.14. What is the ratio of the % of value added in manufacturing in Singapore in 1975 to that in 1976?
Make the answer very short. 1.08. What is the ratio of the % of value added in manufacturing of Ireland in 1975 to that in 1977?
Your answer should be compact. 1.12. What is the ratio of the % of value added in manufacturing of Nigeria in 1975 to that in 1977?
Your response must be concise. 1.21. What is the ratio of the % of value added in manufacturing of Singapore in 1975 to that in 1977?
Offer a terse response. 1.04. What is the ratio of the % of value added in manufacturing of Ireland in 1975 to that in 1978?
Your answer should be compact. 1.12. What is the ratio of the % of value added in manufacturing in Malaysia in 1975 to that in 1978?
Your response must be concise. 1.05. What is the ratio of the % of value added in manufacturing in Nigeria in 1975 to that in 1978?
Make the answer very short. 1.02. What is the ratio of the % of value added in manufacturing of Singapore in 1975 to that in 1978?
Make the answer very short. 1.11. What is the ratio of the % of value added in manufacturing of Ireland in 1976 to that in 1977?
Make the answer very short. 1.05. What is the ratio of the % of value added in manufacturing in Malaysia in 1976 to that in 1977?
Make the answer very short. 0.95. What is the ratio of the % of value added in manufacturing of Nigeria in 1976 to that in 1977?
Your answer should be very brief. 1.06. What is the ratio of the % of value added in manufacturing in Singapore in 1976 to that in 1977?
Give a very brief answer. 0.96. What is the ratio of the % of value added in manufacturing in Ireland in 1976 to that in 1978?
Your answer should be very brief. 1.05. What is the ratio of the % of value added in manufacturing in Nigeria in 1976 to that in 1978?
Give a very brief answer. 0.89. What is the ratio of the % of value added in manufacturing of Singapore in 1976 to that in 1978?
Offer a very short reply. 1.03. What is the ratio of the % of value added in manufacturing in Malaysia in 1977 to that in 1978?
Provide a succinct answer. 1.06. What is the ratio of the % of value added in manufacturing in Nigeria in 1977 to that in 1978?
Provide a short and direct response. 0.84. What is the ratio of the % of value added in manufacturing in Singapore in 1977 to that in 1978?
Keep it short and to the point. 1.07. What is the difference between the highest and the second highest % of value added in manufacturing of Ireland?
Your response must be concise. 2.19. What is the difference between the highest and the second highest % of value added in manufacturing of Malaysia?
Your response must be concise. 0.28. What is the difference between the highest and the second highest % of value added in manufacturing in Nigeria?
Make the answer very short. 5.78. What is the difference between the highest and the second highest % of value added in manufacturing of Singapore?
Ensure brevity in your answer.  0.65. What is the difference between the highest and the lowest % of value added in manufacturing of Ireland?
Provide a short and direct response. 4.1. What is the difference between the highest and the lowest % of value added in manufacturing in Malaysia?
Your answer should be very brief. 4.22. What is the difference between the highest and the lowest % of value added in manufacturing in Nigeria?
Your response must be concise. 14.87. What is the difference between the highest and the lowest % of value added in manufacturing in Singapore?
Provide a succinct answer. 1.36. 